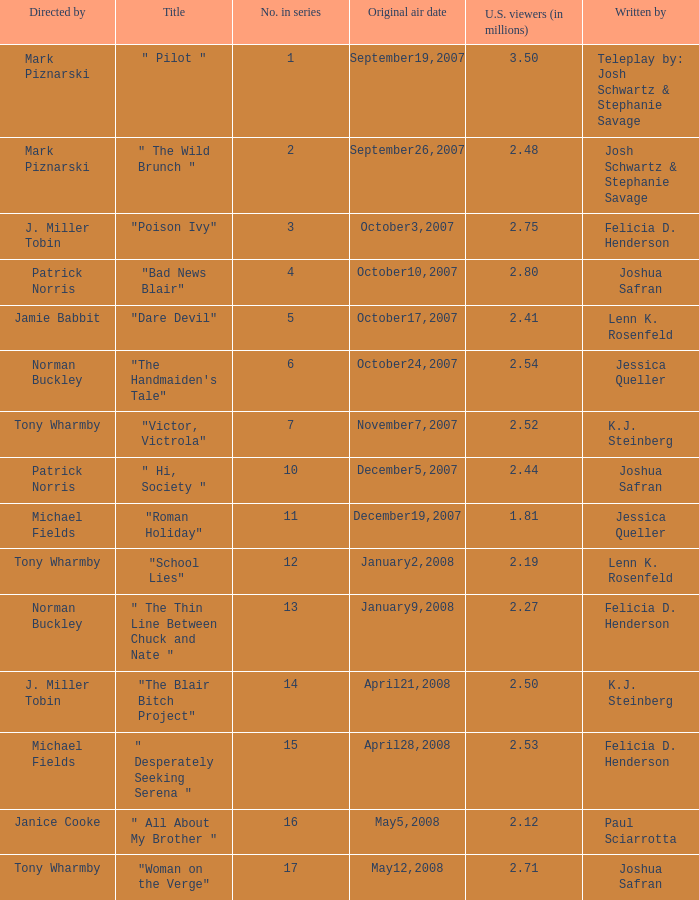How many directed by have 2.80 as u.s. viewers  (in millions)? 1.0. 